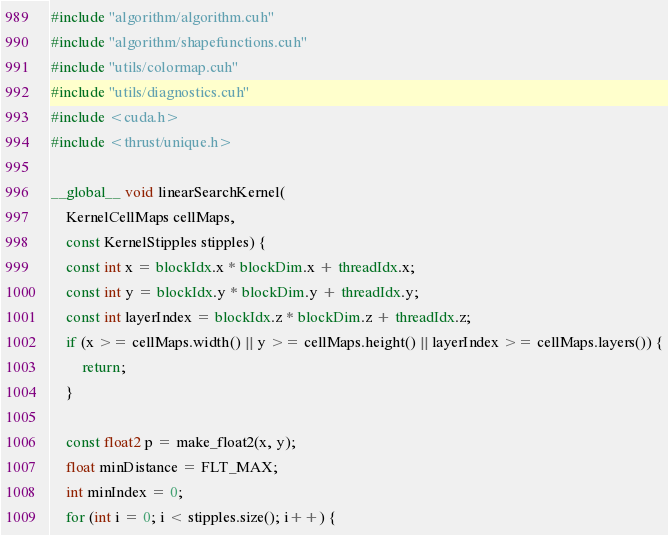Convert code to text. <code><loc_0><loc_0><loc_500><loc_500><_Cuda_>#include "algorithm/algorithm.cuh"
#include "algorithm/shapefunctions.cuh"
#include "utils/colormap.cuh"
#include "utils/diagnostics.cuh"
#include <cuda.h>
#include <thrust/unique.h>

__global__ void linearSearchKernel(
    KernelCellMaps cellMaps,
    const KernelStipples stipples) {
    const int x = blockIdx.x * blockDim.x + threadIdx.x;
    const int y = blockIdx.y * blockDim.y + threadIdx.y;
    const int layerIndex = blockIdx.z * blockDim.z + threadIdx.z;
    if (x >= cellMaps.width() || y >= cellMaps.height() || layerIndex >= cellMaps.layers()) {
        return;
    }

    const float2 p = make_float2(x, y);
    float minDistance = FLT_MAX;
    int minIndex = 0;
    for (int i = 0; i < stipples.size(); i++) {</code> 